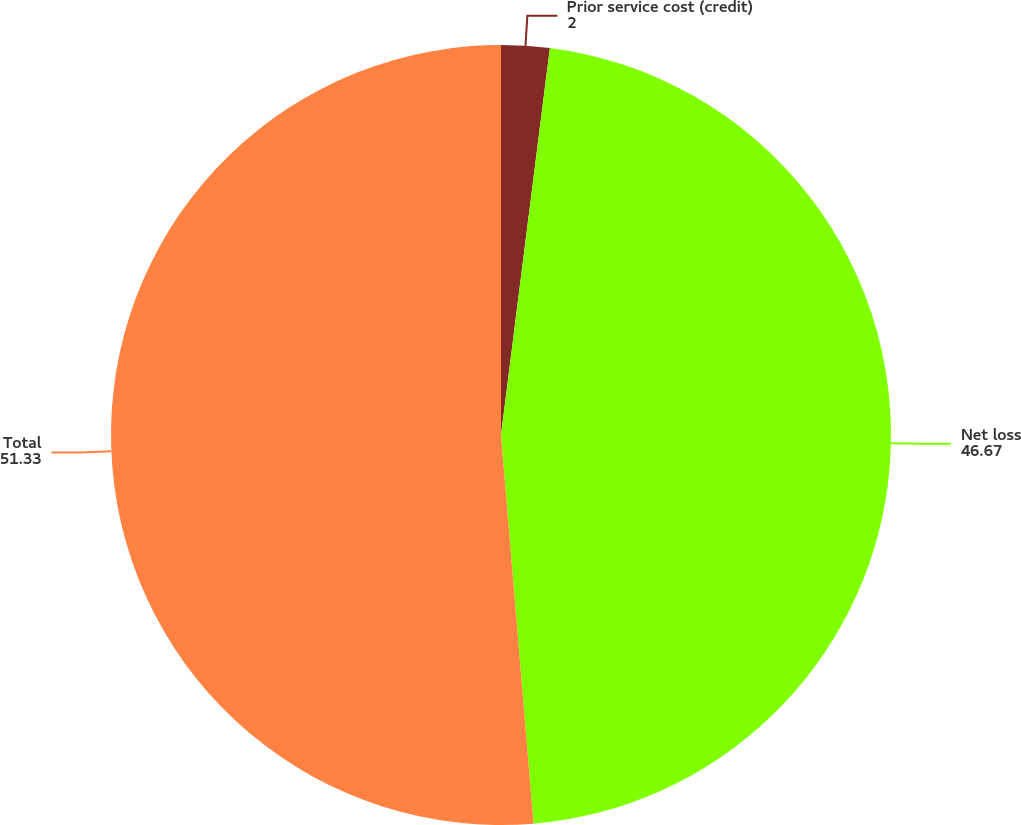Convert chart. <chart><loc_0><loc_0><loc_500><loc_500><pie_chart><fcel>Prior service cost (credit)<fcel>Net loss<fcel>Total<nl><fcel>2.0%<fcel>46.67%<fcel>51.33%<nl></chart> 